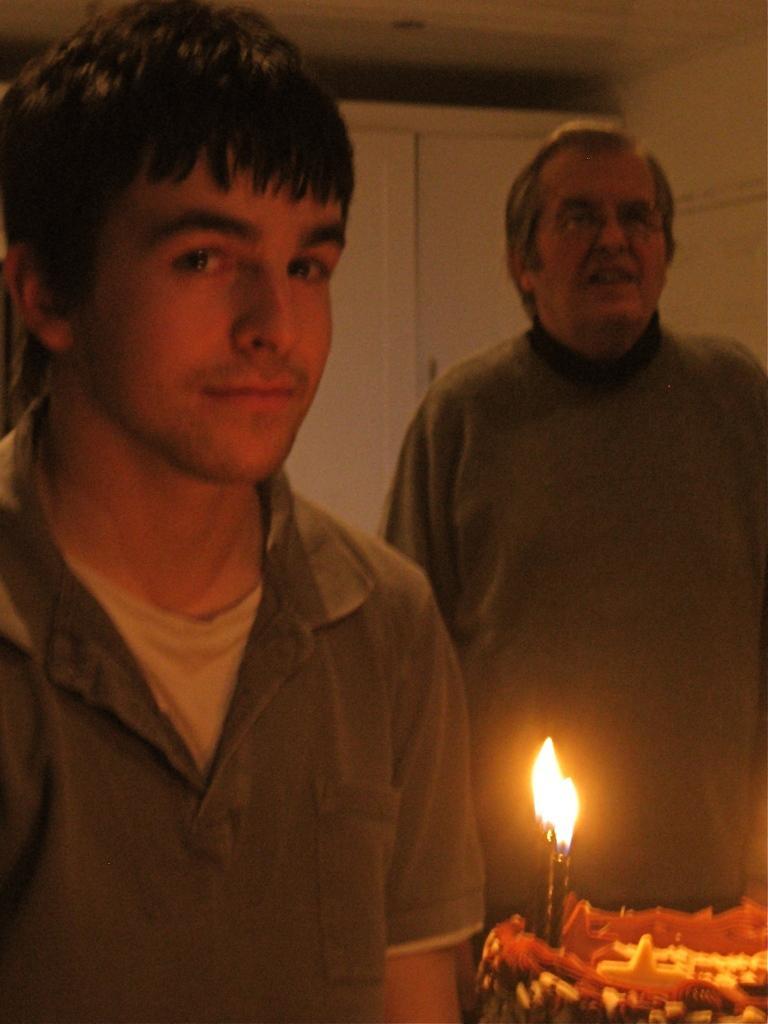In one or two sentences, can you explain what this image depicts? On the left side of the image we can see the boy wearing a green color dress. On the right side of the image we can see a person wearing green color dress and two candles and a cake is there. 